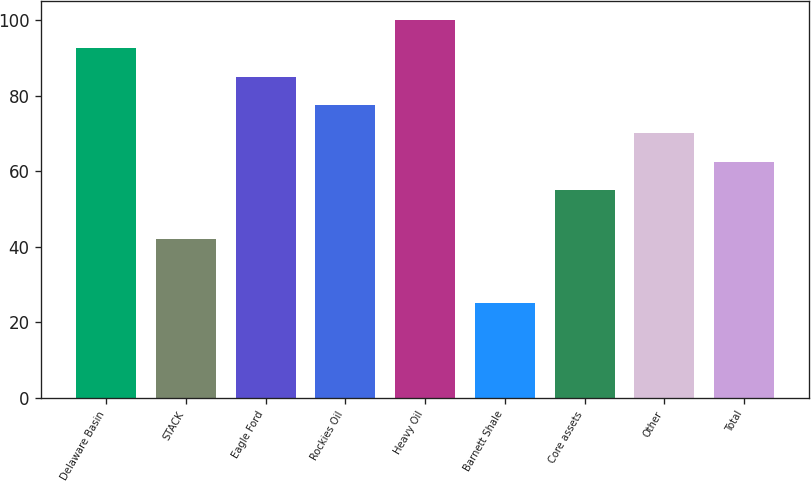<chart> <loc_0><loc_0><loc_500><loc_500><bar_chart><fcel>Delaware Basin<fcel>STACK<fcel>Eagle Ford<fcel>Rockies Oil<fcel>Heavy Oil<fcel>Barnett Shale<fcel>Core assets<fcel>Other<fcel>Total<nl><fcel>92.5<fcel>42<fcel>85<fcel>77.5<fcel>100<fcel>25<fcel>55<fcel>70<fcel>62.5<nl></chart> 